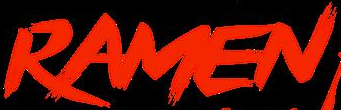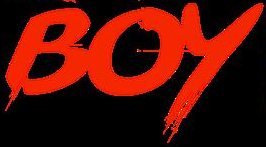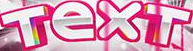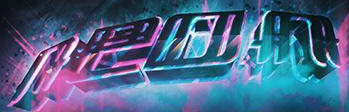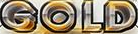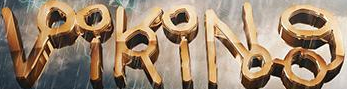What text appears in these images from left to right, separated by a semicolon? RAMEN; BOY; TexT; neon; GOLD; VikiNg 